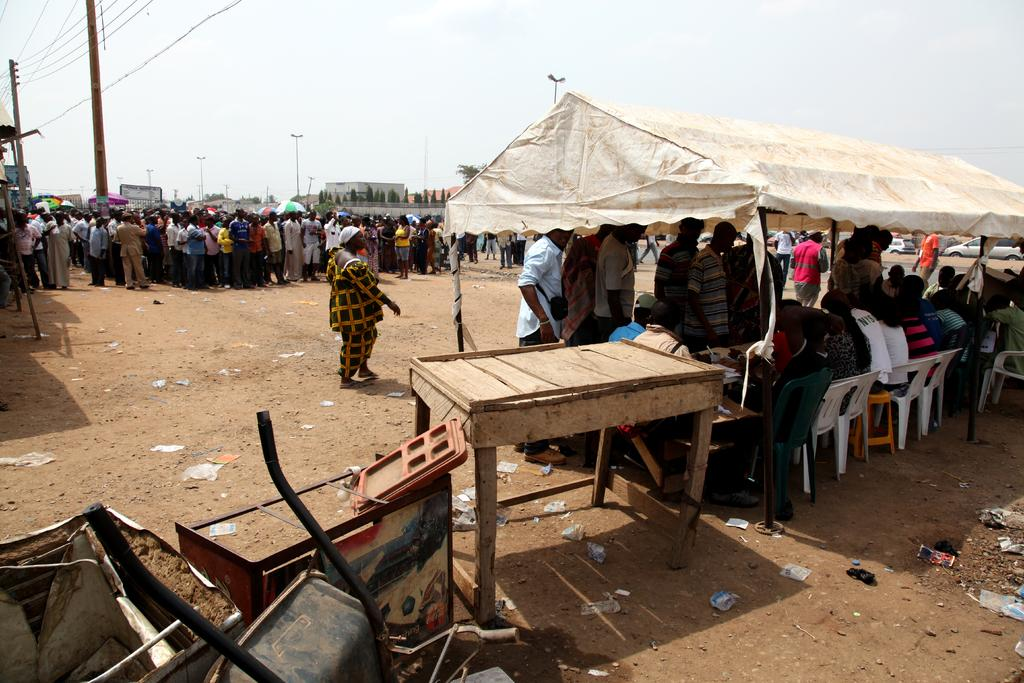What can be seen in the background of the image? The sky is visible in the image. What type of shelter is present in the image? There is a tent in the image. Are there any people in the image? Yes, there are people in the image. What is one woman doing in the image? One woman is walking in the image. What type of furniture is on the ground in the image? There are chairs on the ground in the image. What type of iron is being used to cook the goldfish in the image? There is no iron or goldfish present in the image. 